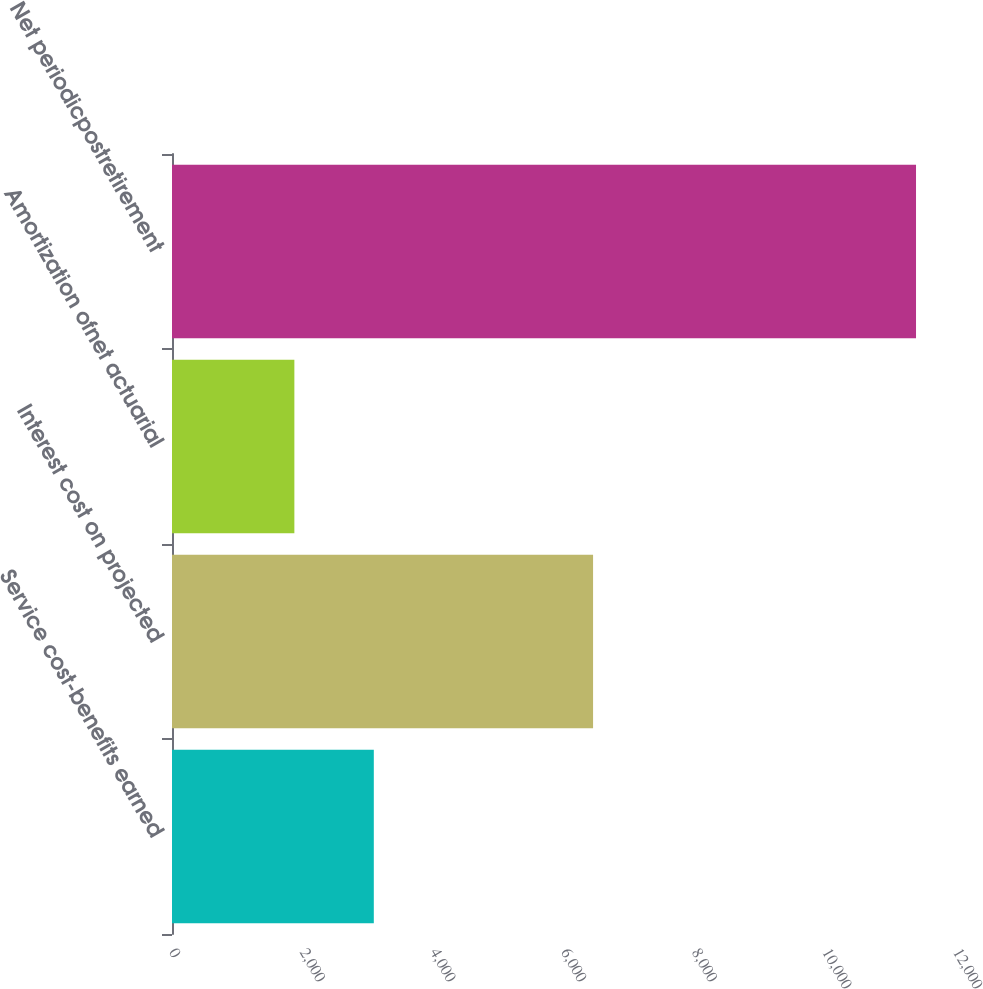Convert chart. <chart><loc_0><loc_0><loc_500><loc_500><bar_chart><fcel>Service cost-benefits earned<fcel>Interest cost on projected<fcel>Amortization ofnet actuarial<fcel>Net periodicpostretirement<nl><fcel>3089<fcel>6445<fcel>1873<fcel>11388<nl></chart> 